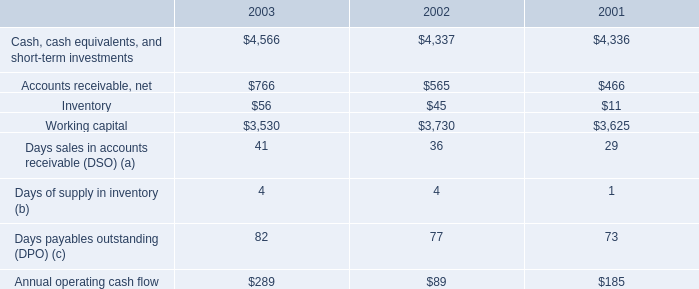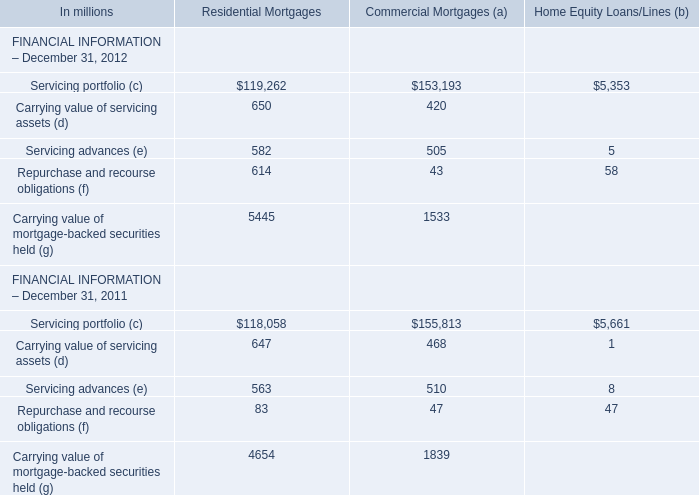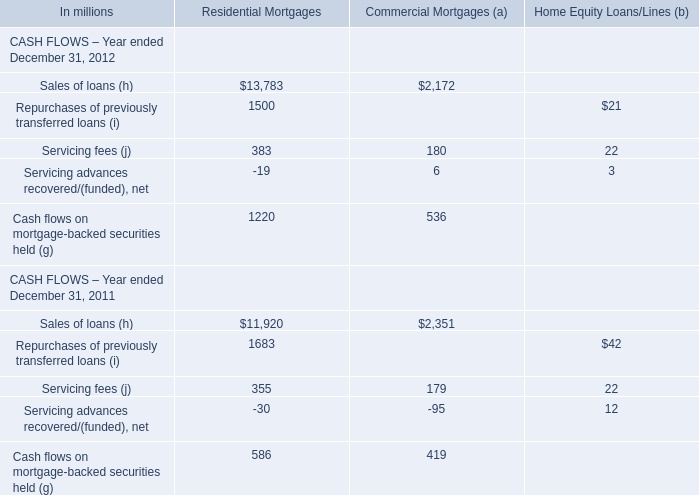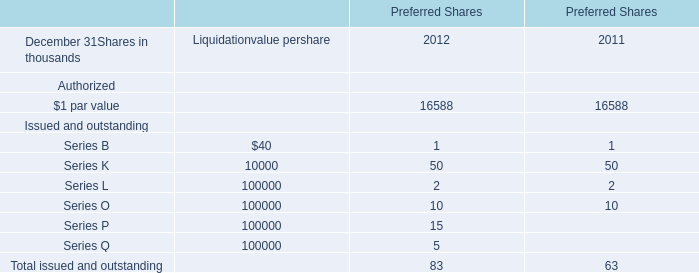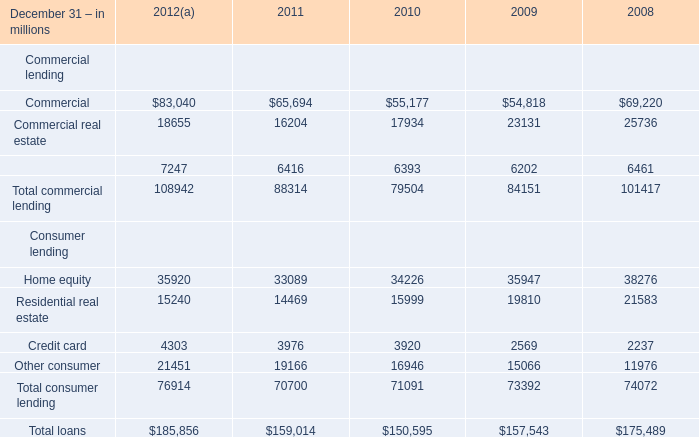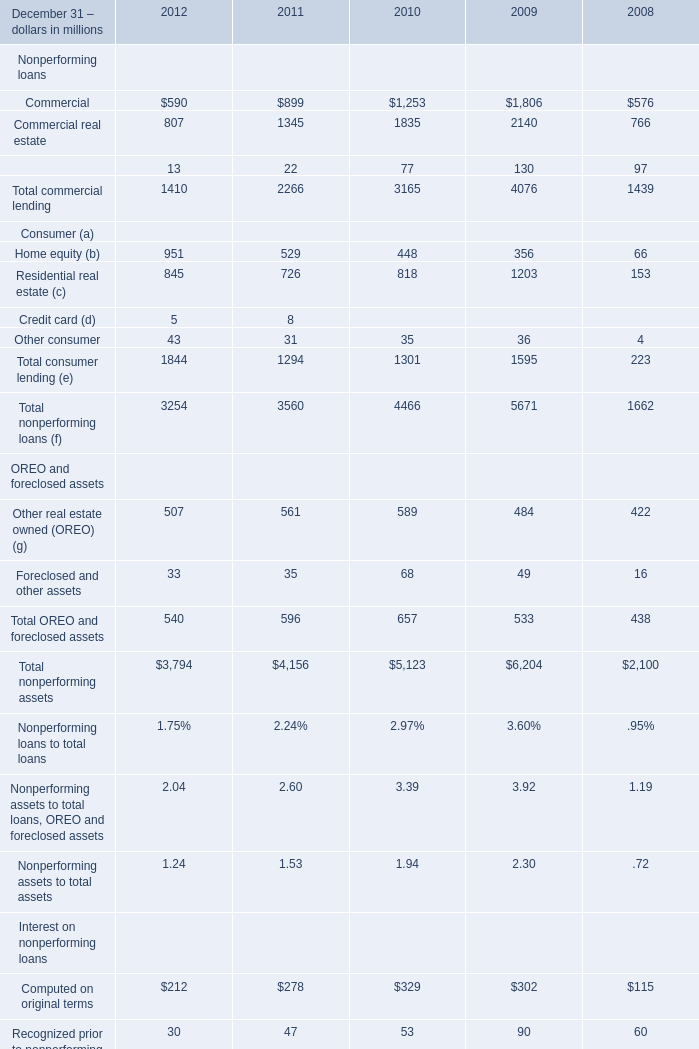What is the total value of the Equipment lease financing at December 31,2010 and the Total consumer lending at December 31,2010? (in million) 
Computations: (6393 + 71091)
Answer: 77484.0. 